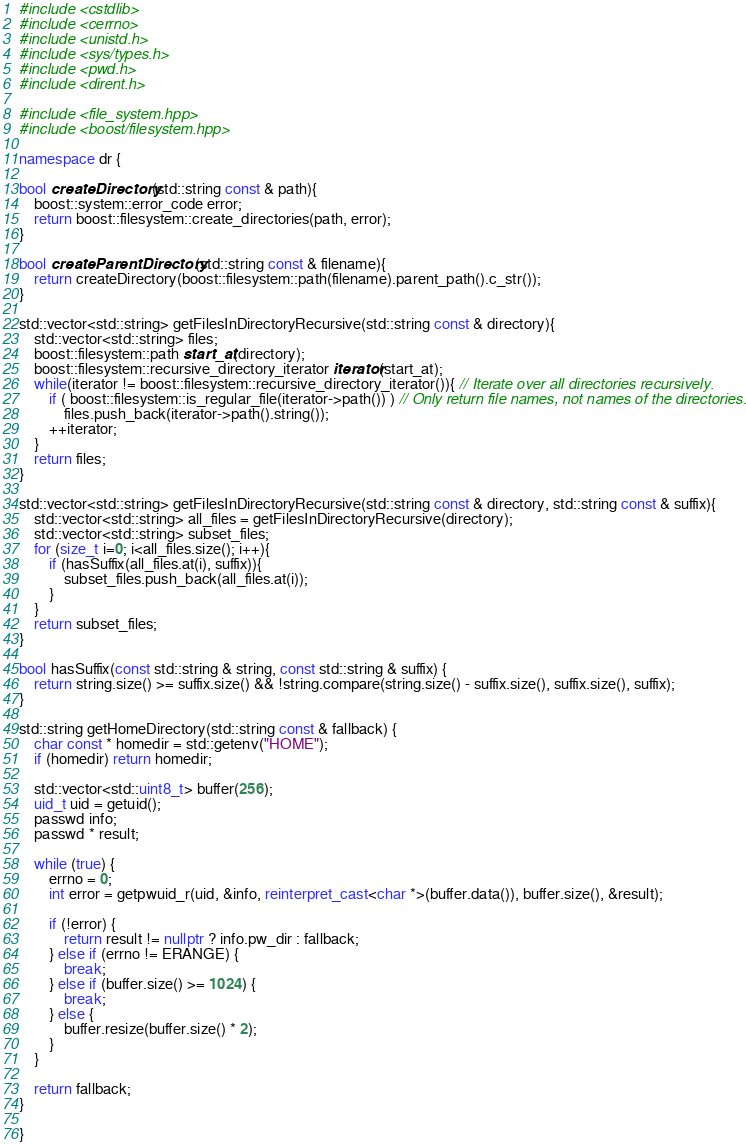<code> <loc_0><loc_0><loc_500><loc_500><_C++_>#include <cstdlib>
#include <cerrno>
#include <unistd.h>
#include <sys/types.h>
#include <pwd.h>
#include <dirent.h>

#include <file_system.hpp>
#include <boost/filesystem.hpp>

namespace dr {

bool createDirectory(std::string const & path){
	boost::system::error_code error;
	return boost::filesystem::create_directories(path, error);
}

bool createParentDirectory(std::string const & filename){
	return createDirectory(boost::filesystem::path(filename).parent_path().c_str());
}

std::vector<std::string> getFilesInDirectoryRecursive(std::string const & directory){
	std::vector<std::string> files;
	boost::filesystem::path start_at(directory);
	boost::filesystem::recursive_directory_iterator iterator(start_at);
	while(iterator != boost::filesystem::recursive_directory_iterator()){ // Iterate over all directories recursively.
		if ( boost::filesystem::is_regular_file(iterator->path()) ) // Only return file names, not names of the directories.
			files.push_back(iterator->path().string());
		++iterator;
	}
	return files;
}

std::vector<std::string> getFilesInDirectoryRecursive(std::string const & directory, std::string const & suffix){
	std::vector<std::string> all_files = getFilesInDirectoryRecursive(directory);
	std::vector<std::string> subset_files;
	for (size_t i=0; i<all_files.size(); i++){
		if (hasSuffix(all_files.at(i), suffix)){
			subset_files.push_back(all_files.at(i));
		}
	}
	return subset_files;
}

bool hasSuffix(const std::string & string, const std::string & suffix) {
	return string.size() >= suffix.size() && !string.compare(string.size() - suffix.size(), suffix.size(), suffix);
}

std::string getHomeDirectory(std::string const & fallback) {
	char const * homedir = std::getenv("HOME");
	if (homedir) return homedir;

	std::vector<std::uint8_t> buffer(256);
	uid_t uid = getuid();
	passwd info;
	passwd * result;

	while (true) {
		errno = 0;
		int error = getpwuid_r(uid, &info, reinterpret_cast<char *>(buffer.data()), buffer.size(), &result);

		if (!error) {
			return result != nullptr ? info.pw_dir : fallback;
		} else if (errno != ERANGE) {
			break;
		} else if (buffer.size() >= 1024) {
			break;
		} else {
			buffer.resize(buffer.size() * 2);
		}
	}

	return fallback;
}

}
</code> 